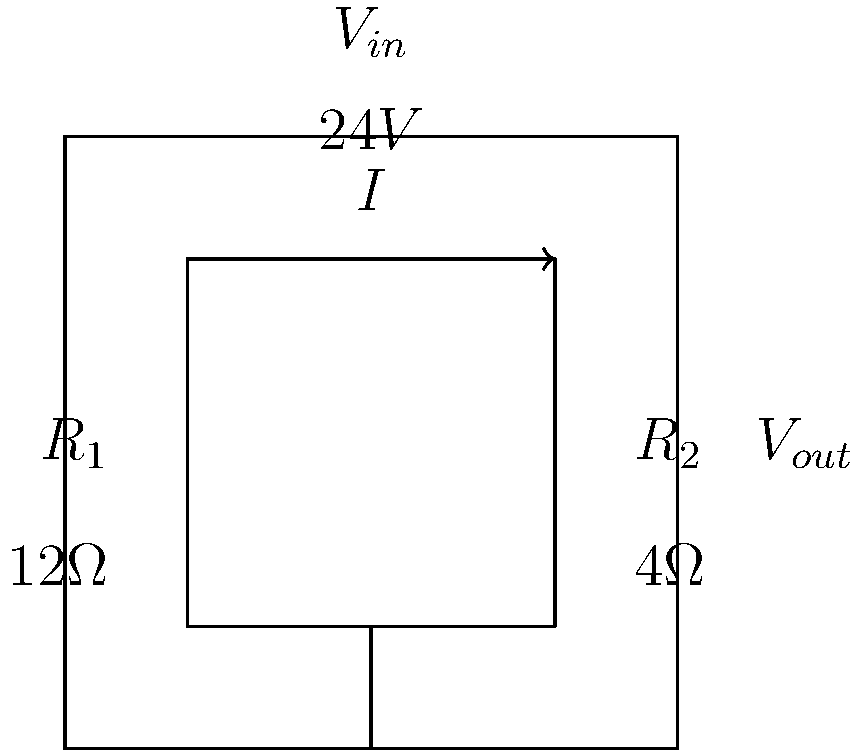As a videographer specializing in salsa performances, you need to calculate the optimal lighting intensity for a performance. The lighting system is controlled by the circuit shown above. If the optimal lighting intensity is achieved when the output voltage ($V_{out}$) is 6V, what should be the current ($I$) flowing through the circuit? To solve this problem, we'll follow these steps:

1) First, we need to identify that this is a voltage divider circuit.

2) In a voltage divider, the output voltage is given by:
   $$V_{out} = V_{in} \cdot \frac{R_2}{R_1 + R_2}$$

3) We're given that $V_{out} = 6V$, $V_{in} = 24V$, $R_1 = 12\Omega$, and $R_2 = 4\Omega$.

4) Let's substitute these values into the voltage divider equation:
   $$6V = 24V \cdot \frac{4\Omega}{12\Omega + 4\Omega}$$

5) This confirms that our circuit is functioning as expected.

6) To find the current, we can use Ohm's Law: $I = \frac{V}{R}$

7) We'll use the total voltage and total resistance:
   $$I = \frac{V_{in}}{R_1 + R_2} = \frac{24V}{12\Omega + 4\Omega} = \frac{24V}{16\Omega}$$

8) Simplifying:
   $$I = 1.5A$$

Therefore, the current flowing through the circuit should be 1.5 amperes to achieve the optimal lighting intensity for the salsa performance.
Answer: $1.5A$ 